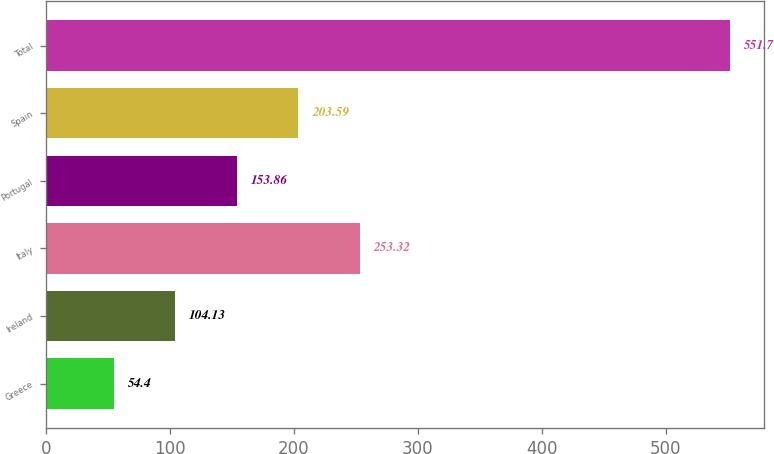<chart> <loc_0><loc_0><loc_500><loc_500><bar_chart><fcel>Greece<fcel>Ireland<fcel>Italy<fcel>Portugal<fcel>Spain<fcel>Total<nl><fcel>54.4<fcel>104.13<fcel>253.32<fcel>153.86<fcel>203.59<fcel>551.7<nl></chart> 